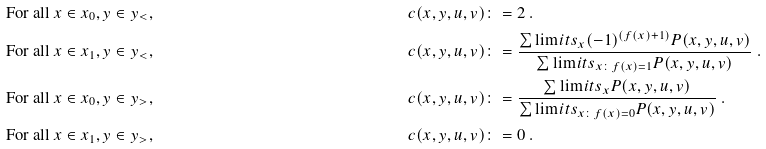<formula> <loc_0><loc_0><loc_500><loc_500>& \text {For all } { x } \in { x } _ { 0 } , { y } \in { y } _ { < } , & & c ( { x , y } , { u , v } ) \colon = 2 \ . \\ & \text {For all } { x } \in { x } _ { 1 } , { y } \in { y } _ { < } , & & c ( { x , y } , { u , v } ) \colon = \frac { \sum \lim i t s _ { x } ( - 1 ) ^ { ( f ( x ) + 1 ) } P ( { { x , y } , { u , v } } ) } { \sum \lim i t s _ { { x } \colon f ( { x } ) = 1 } P ( { { x , y } , { u , v } } ) } \ . \\ & \text {For all } { x } \in { x } _ { 0 } , { y } \in { y } _ { > } , & & c ( { x , y } , { u , v } ) \colon = \frac { \sum \lim i t s _ { x } P ( { { x , y } , { u , v } } ) } { \sum \lim i t s _ { { x } \colon f ( { x } ) = 0 } P ( { { x , y } , { u , v } } ) } \ . \\ & \text {For all } { x } \in { x } _ { 1 } , { y } \in { y } _ { > } , & & c ( { x , y } , { u , v } ) \colon = 0 \ .</formula> 